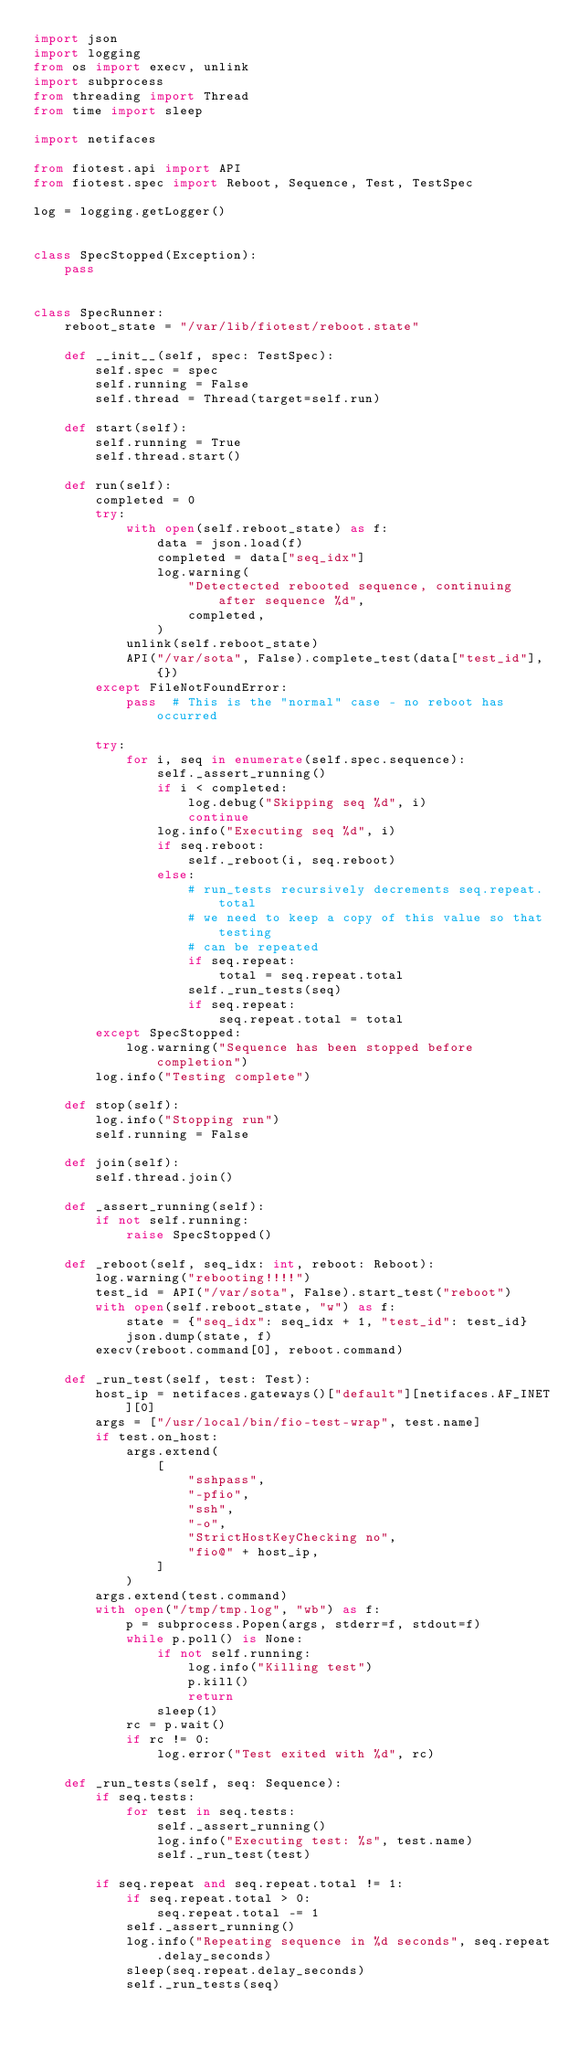<code> <loc_0><loc_0><loc_500><loc_500><_Python_>import json
import logging
from os import execv, unlink
import subprocess
from threading import Thread
from time import sleep

import netifaces

from fiotest.api import API
from fiotest.spec import Reboot, Sequence, Test, TestSpec

log = logging.getLogger()


class SpecStopped(Exception):
    pass


class SpecRunner:
    reboot_state = "/var/lib/fiotest/reboot.state"

    def __init__(self, spec: TestSpec):
        self.spec = spec
        self.running = False
        self.thread = Thread(target=self.run)

    def start(self):
        self.running = True
        self.thread.start()

    def run(self):
        completed = 0
        try:
            with open(self.reboot_state) as f:
                data = json.load(f)
                completed = data["seq_idx"]
                log.warning(
                    "Detectected rebooted sequence, continuing after sequence %d",
                    completed,
                )
            unlink(self.reboot_state)
            API("/var/sota", False).complete_test(data["test_id"], {})
        except FileNotFoundError:
            pass  # This is the "normal" case - no reboot has occurred

        try:
            for i, seq in enumerate(self.spec.sequence):
                self._assert_running()
                if i < completed:
                    log.debug("Skipping seq %d", i)
                    continue
                log.info("Executing seq %d", i)
                if seq.reboot:
                    self._reboot(i, seq.reboot)
                else:
                    # run_tests recursively decrements seq.repeat.total
                    # we need to keep a copy of this value so that testing
                    # can be repeated
                    if seq.repeat:
                        total = seq.repeat.total
                    self._run_tests(seq)
                    if seq.repeat:
                        seq.repeat.total = total
        except SpecStopped:
            log.warning("Sequence has been stopped before completion")
        log.info("Testing complete")

    def stop(self):
        log.info("Stopping run")
        self.running = False

    def join(self):
        self.thread.join()

    def _assert_running(self):
        if not self.running:
            raise SpecStopped()

    def _reboot(self, seq_idx: int, reboot: Reboot):
        log.warning("rebooting!!!!")
        test_id = API("/var/sota", False).start_test("reboot")
        with open(self.reboot_state, "w") as f:
            state = {"seq_idx": seq_idx + 1, "test_id": test_id}
            json.dump(state, f)
        execv(reboot.command[0], reboot.command)

    def _run_test(self, test: Test):
        host_ip = netifaces.gateways()["default"][netifaces.AF_INET][0]
        args = ["/usr/local/bin/fio-test-wrap", test.name]
        if test.on_host:
            args.extend(
                [
                    "sshpass",
                    "-pfio",
                    "ssh",
                    "-o",
                    "StrictHostKeyChecking no",
                    "fio@" + host_ip,
                ]
            )
        args.extend(test.command)
        with open("/tmp/tmp.log", "wb") as f:
            p = subprocess.Popen(args, stderr=f, stdout=f)
            while p.poll() is None:
                if not self.running:
                    log.info("Killing test")
                    p.kill()
                    return
                sleep(1)
            rc = p.wait()
            if rc != 0:
                log.error("Test exited with %d", rc)

    def _run_tests(self, seq: Sequence):
        if seq.tests:
            for test in seq.tests:
                self._assert_running()
                log.info("Executing test: %s", test.name)
                self._run_test(test)

        if seq.repeat and seq.repeat.total != 1:
            if seq.repeat.total > 0:
                seq.repeat.total -= 1
            self._assert_running()
            log.info("Repeating sequence in %d seconds", seq.repeat.delay_seconds)
            sleep(seq.repeat.delay_seconds)
            self._run_tests(seq)
</code> 